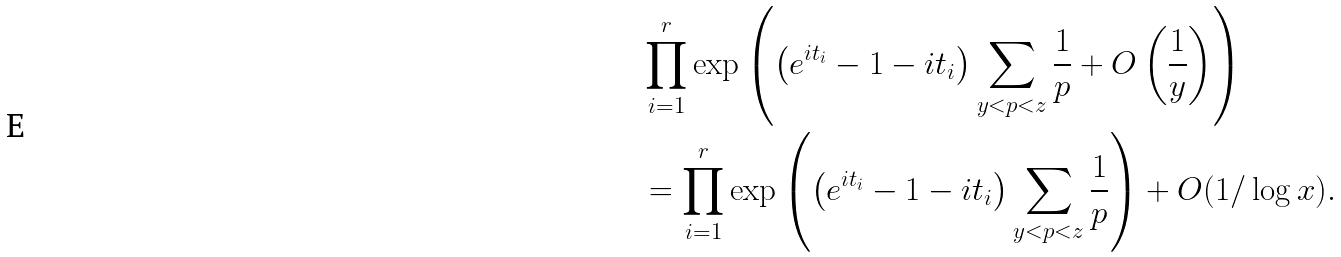<formula> <loc_0><loc_0><loc_500><loc_500>& \prod _ { i = 1 } ^ { r } \exp \left ( \left ( e ^ { { i } t _ { i } } - 1 - { i } t _ { i } \right ) \sum _ { y < p < z } \frac { 1 } { p } + O \left ( \frac { 1 } { y } \right ) \right ) \\ & = \prod _ { i = 1 } ^ { r } \exp \left ( \left ( e ^ { { i } t _ { i } } - 1 - { i } t _ { i } \right ) \sum _ { y < p < z } \frac { 1 } { p } \right ) + O ( 1 / \log x ) .</formula> 